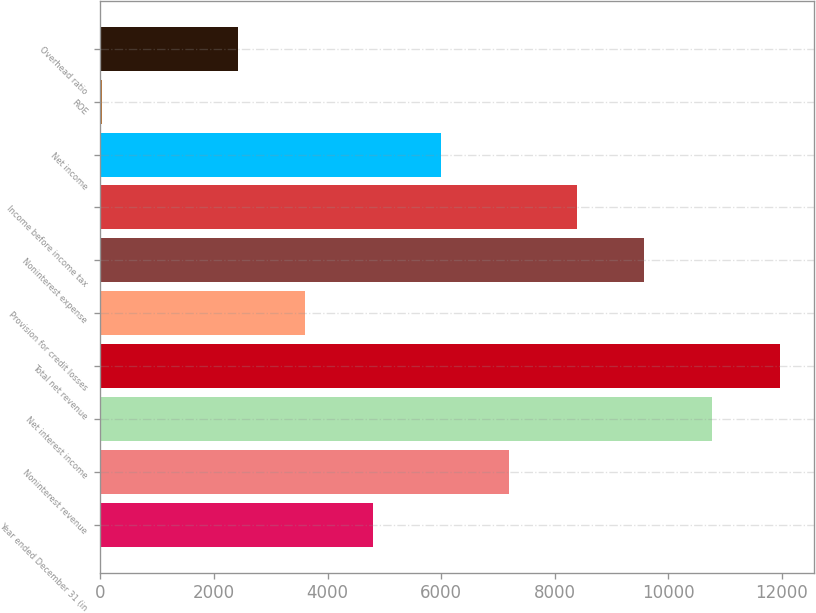<chart> <loc_0><loc_0><loc_500><loc_500><bar_chart><fcel>Year ended December 31 (in<fcel>Noninterest revenue<fcel>Net interest income<fcel>Total net revenue<fcel>Provision for credit losses<fcel>Noninterest expense<fcel>Income before income tax<fcel>Net income<fcel>ROE<fcel>Overhead ratio<nl><fcel>4805<fcel>7194<fcel>10777.5<fcel>11972<fcel>3610.5<fcel>9583<fcel>8388.5<fcel>5999.5<fcel>27<fcel>2416<nl></chart> 